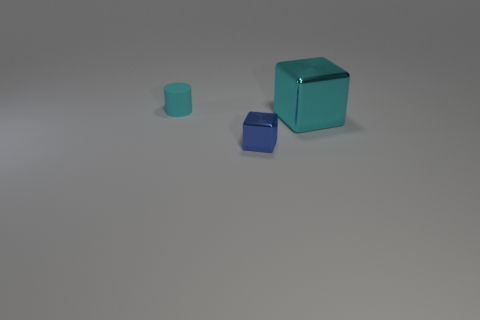Is there anything else that has the same material as the small cyan cylinder?
Your answer should be very brief. No. Do the cyan object that is on the left side of the blue metal cube and the cyan thing right of the tiny blue thing have the same material?
Ensure brevity in your answer.  No. Is the number of large cubes on the left side of the matte thing the same as the number of rubber things that are on the left side of the big cyan thing?
Your answer should be compact. No. There is a cylinder that is the same size as the blue metallic object; what color is it?
Give a very brief answer. Cyan. Is there another thing that has the same color as the large thing?
Your response must be concise. Yes. How many things are either tiny objects that are in front of the small rubber thing or shiny things?
Offer a very short reply. 2. What number of other objects are the same size as the cyan shiny object?
Keep it short and to the point. 0. What is the block left of the block that is behind the block that is left of the big block made of?
Offer a very short reply. Metal. How many cylinders are green metallic things or blue metal objects?
Your answer should be compact. 0. Are there any other things that are the same shape as the matte thing?
Keep it short and to the point. No. 